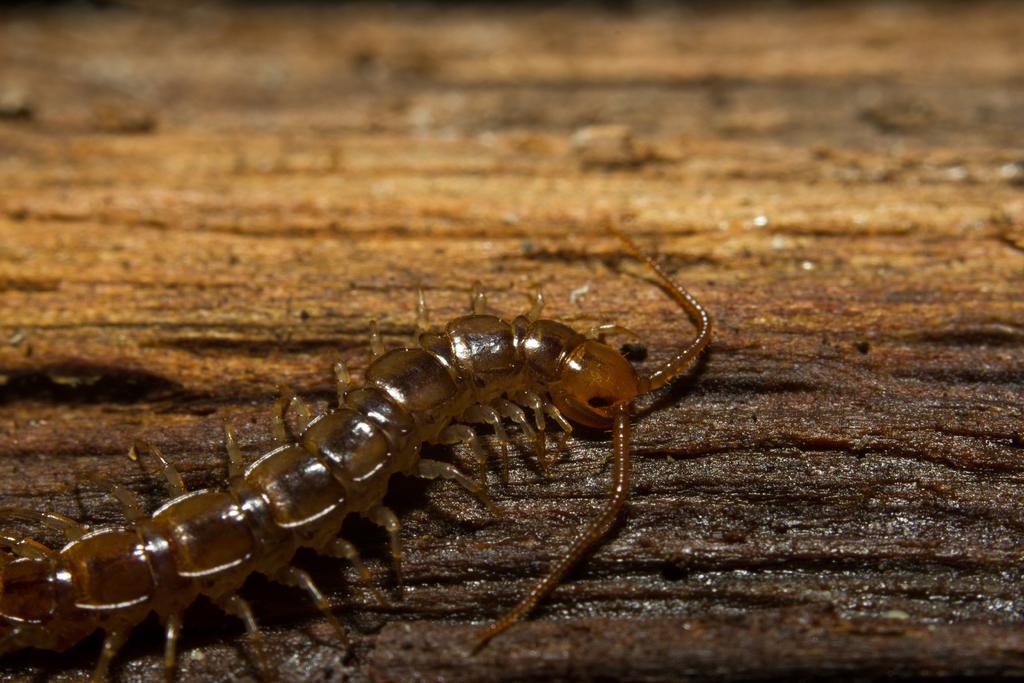Can you describe this image briefly? In this image I can see an insect in brown color and the insect is on the brown color surface. 